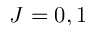Convert formula to latex. <formula><loc_0><loc_0><loc_500><loc_500>J = 0 , 1</formula> 